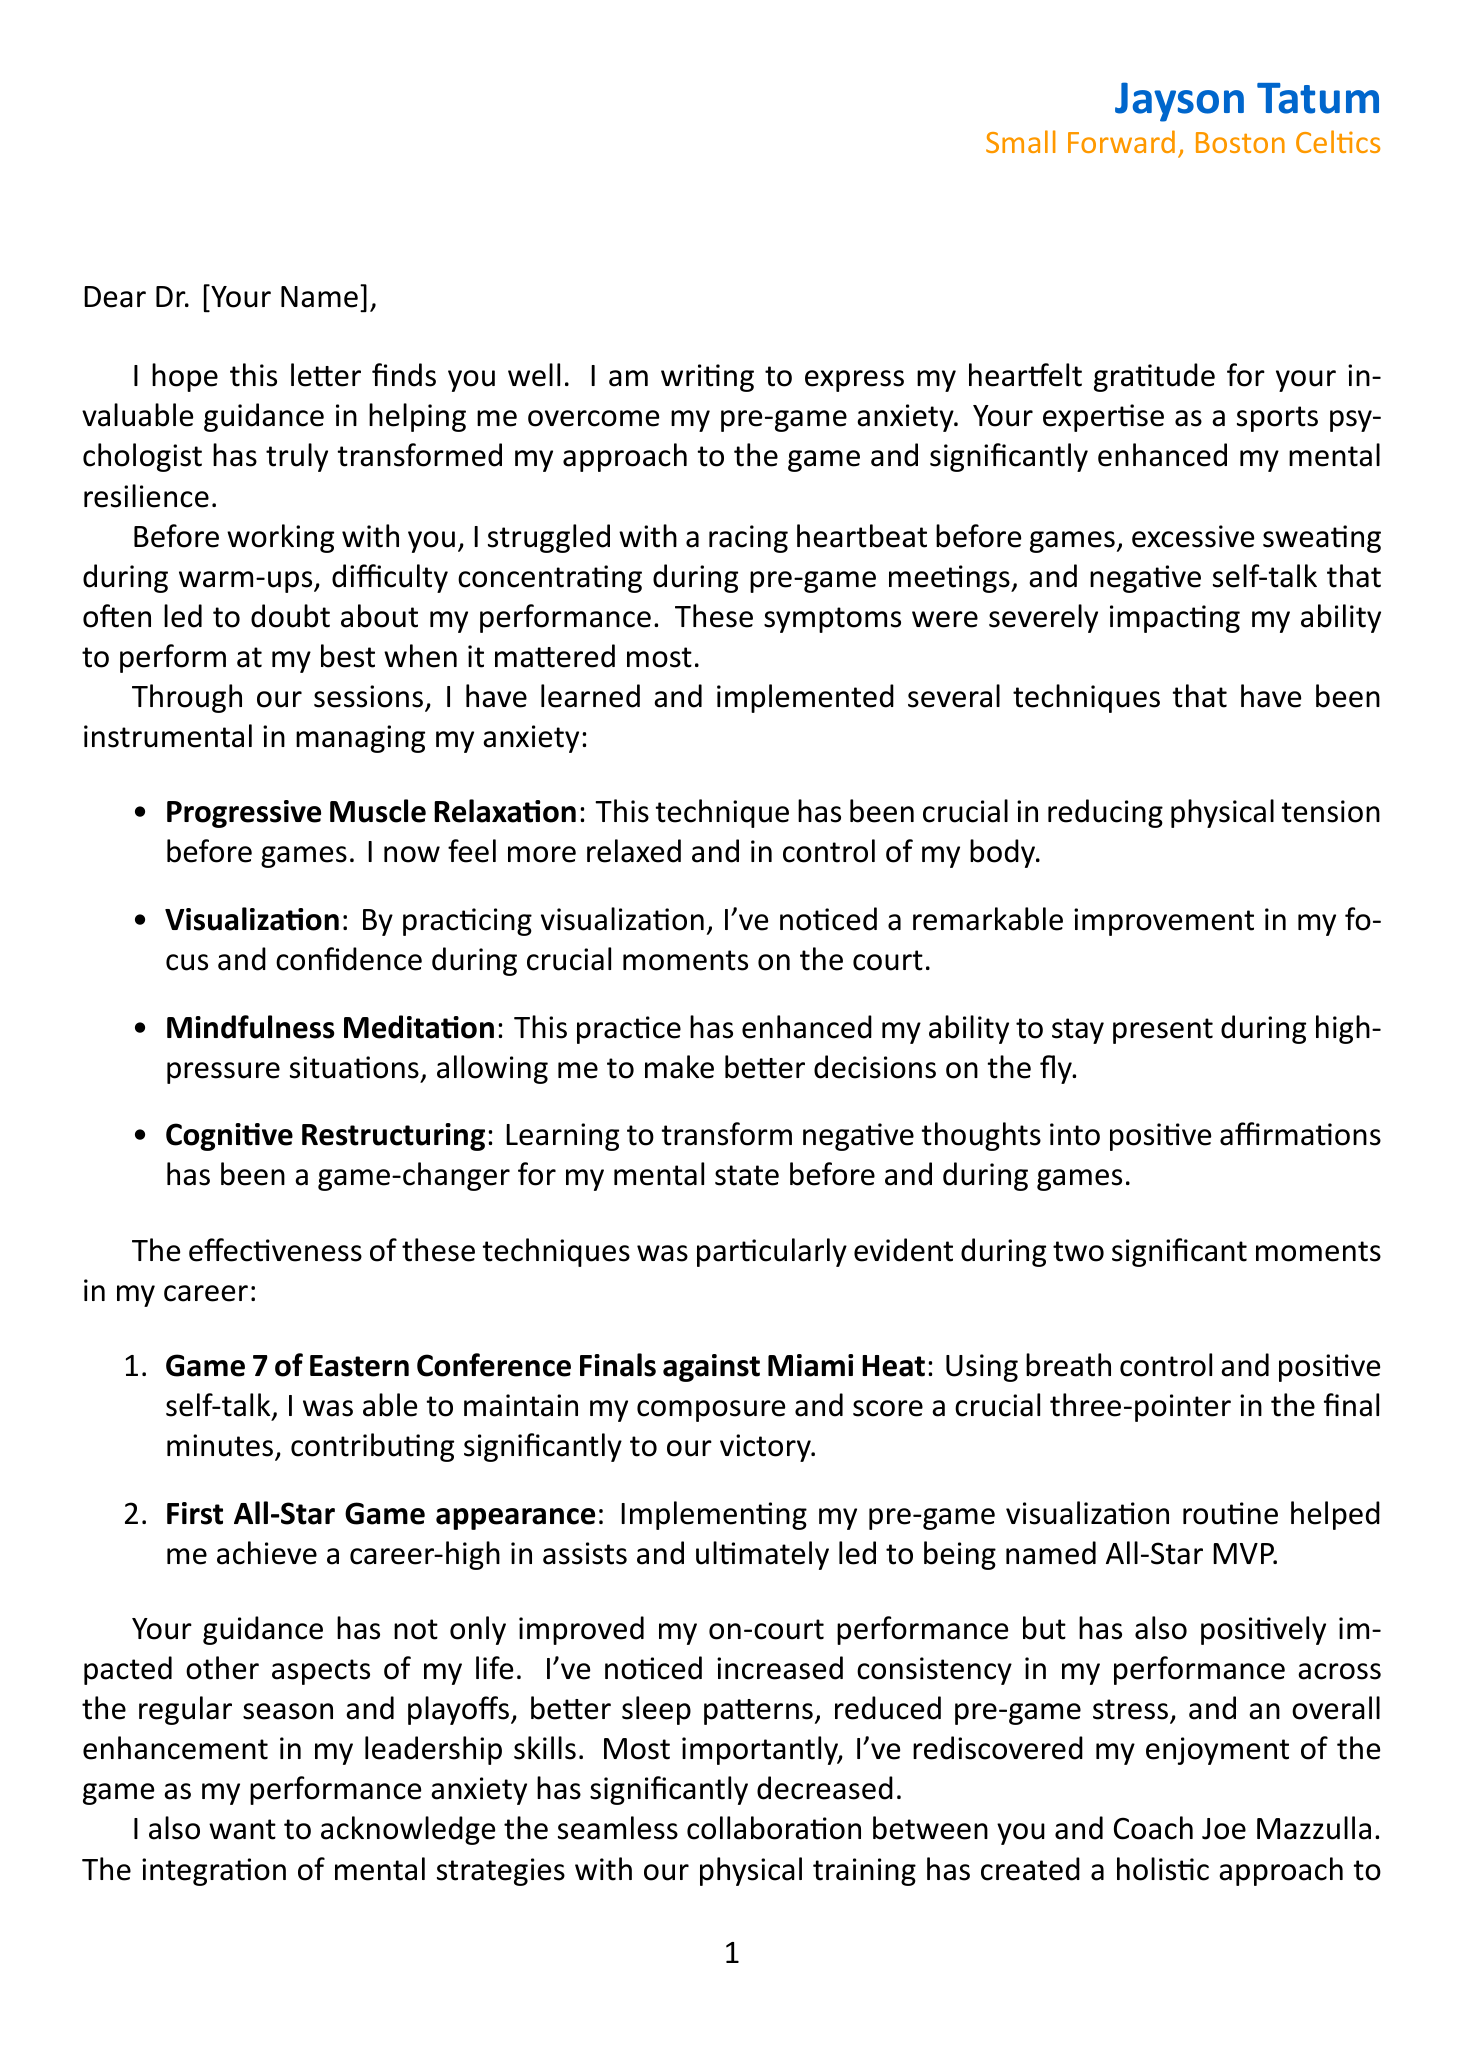What is the player's name? The player's name is mentioned in the signature of the letter.
Answer: Jayson Tatum What team does the player represent? The team name is provided in the player's details section of the letter.
Answer: Boston Celtics What technique helped reduce physical tension before games? This technique is listed in the body of the letter as effective for managing anxiety.
Answer: Progressive Muscle Relaxation During which game did the player score a crucial three-pointer? The game is specified in the example part of the letter highlighting significant experiences.
Answer: Game 7 of Eastern Conference Finals against Miami Heat What was the outcome of the player's first All-Star Game appearance? This outcome is featured in the success story section, detailing the impact of visualization.
Answer: Named All-Star MVP What are the improvements noted in the player's overall performance? This is summarized in the letter under overall improvements, detailing multiple positive changes.
Answer: Increased consistency in performance across regular season and playoffs Who is the coach mentioned in collaboration with the sports psychologist? The coach's name is included in the collaboration section of the document.
Answer: Joe Mazzulla What is the player's position in the team? The position is stated in the player's details section of the letter.
Answer: Small Forward What future plan involves mentoring younger players? The player's intentions regarding mentoring are outlined in the future plans section of the letter.
Answer: Mentor younger players on the importance of mental preparation 